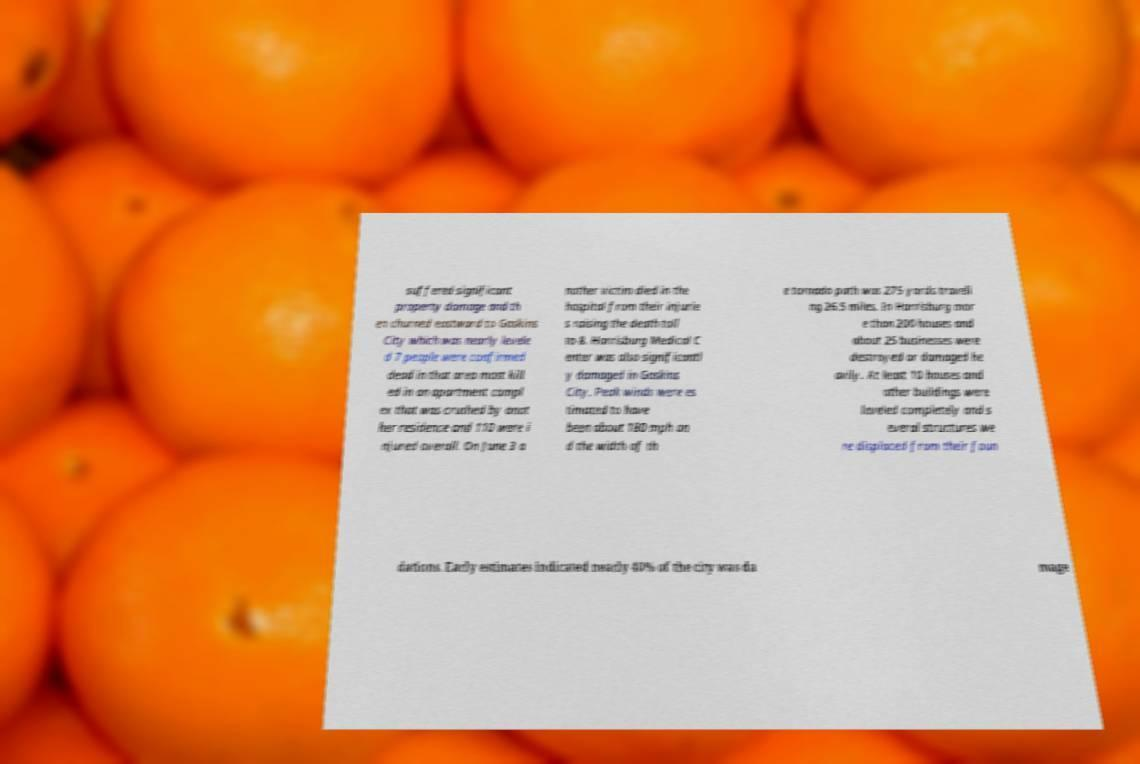Could you extract and type out the text from this image? suffered significant property damage and th en churned eastward to Gaskins City which was nearly levele d 7 people were confirmed dead in that area most kill ed in an apartment compl ex that was crushed by anot her residence and 110 were i njured overall. On June 3 a nother victim died in the hospital from their injurie s raising the death toll to 8. Harrisburg Medical C enter was also significantl y damaged in Gaskins City. Peak winds were es timated to have been about 180 mph an d the width of th e tornado path was 275 yards traveli ng 26.5 miles. In Harrisburg mor e than 200 houses and about 25 businesses were destroyed or damaged he avily. At least 10 houses and other buildings were leveled completely and s everal structures we re displaced from their foun dations. Early estimates indicated nearly 40% of the city was da mage 